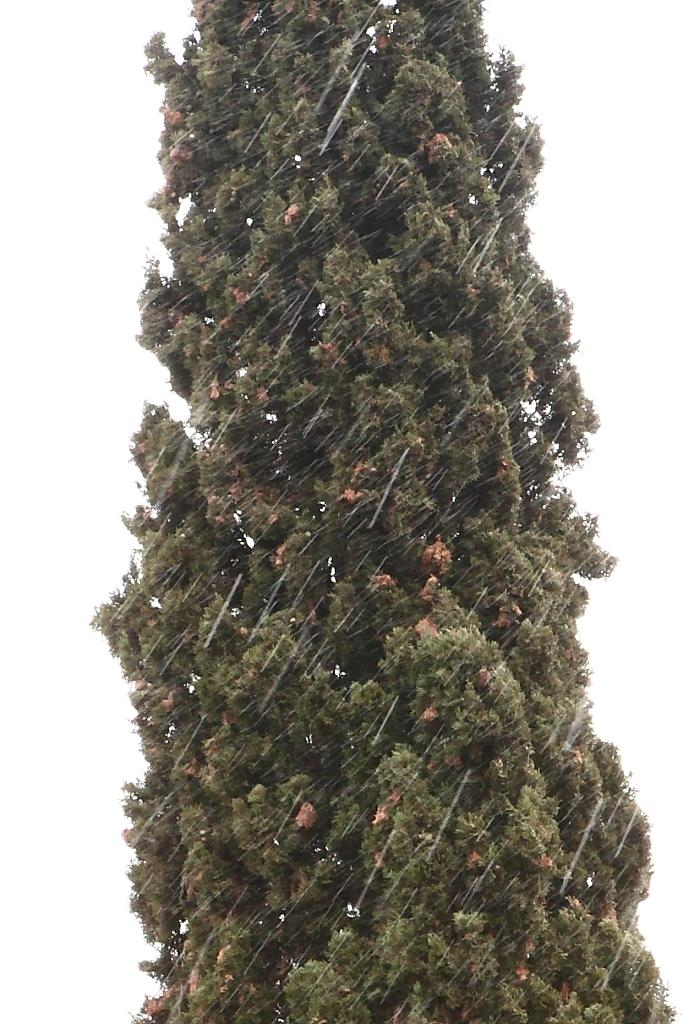What is the main subject of the picture? The main subject of the picture is a tree. Where is the tree located in the image? The tree is in the middle of the picture. What color is the background of the image? The background of the image is white. What type of sofa can be seen in the image? There is no sofa present in the image; it features a tree in the middle of a white background. What authority figure is depicted in the image? There is no authority figure present in the image; it features a tree in the middle of a white background. 